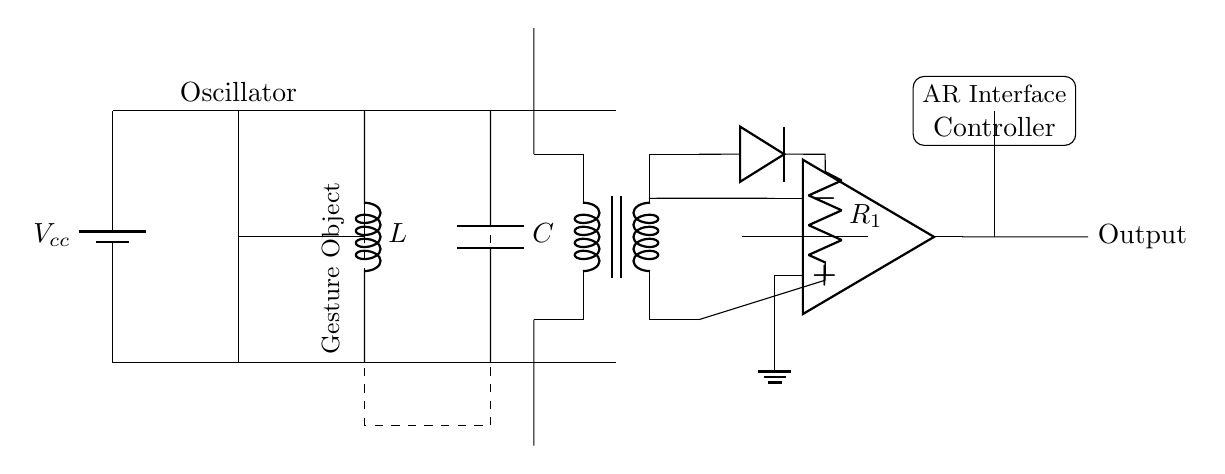What is the function of the oscillator in this circuit? The oscillator generates a periodic signal that is necessary for the operation of the inductive proximity sensor. This signal is used to create an alternating magnetic field, which is essential for detecting nearby gestures.
Answer: oscillator What does the capacitor do in this circuit? The capacitor is used to smooth out voltage fluctuations and filter the signal in the circuit. It helps to stabilize the voltage supplied to the inductive coil and rectifier, ensuring consistent operation.
Answer: C What is the relationship between the inductor and the gesture object? The inductor creates an electromagnetic field that interacts with the gesture object. When a gesture enters this field, it causes a change in the inductance, enabling detection.
Answer: electromagnetic field How many resistors are present in this circuit? There is one resistor named R1, which is part of the rectification stage of the circuit.
Answer: 1 What is the purpose of the rectifier in this circuit? The rectifier converts the alternating current from the oscillator and inductor into direct current, which is then processed by the comparator to detect gestures. This is essential for translating the sensor's input into a usable output signal for gesture recognition.
Answer: rectification Which component provides the output of the circuit? The output is provided by the operational amplifier (op amp), which processes the signal from the rectifier and provides a definitive output based on the detected gestures.
Answer: op amp What type of sensors can be used for gesture recognition in augmented reality? Inductive proximity sensors, like the one represented in this circuit, utilize electromagnetic fields for gesture recognition. They are particularly effective in AR applications where precise detection of movements is required.
Answer: inductive proximity sensors 